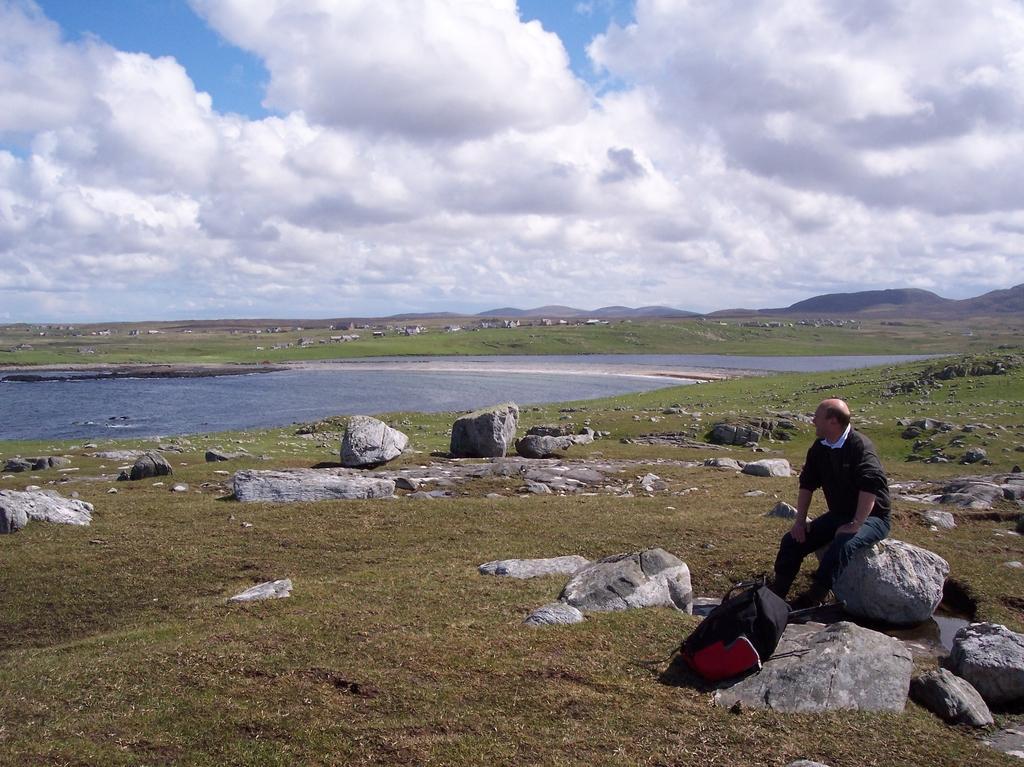Can you describe this image briefly? In this picture we can see a man sitting on a rock, at the bottom there is grass, we can see a bag here, there are some rocks here, we can see water here, there is the sky at the top of the picture. 